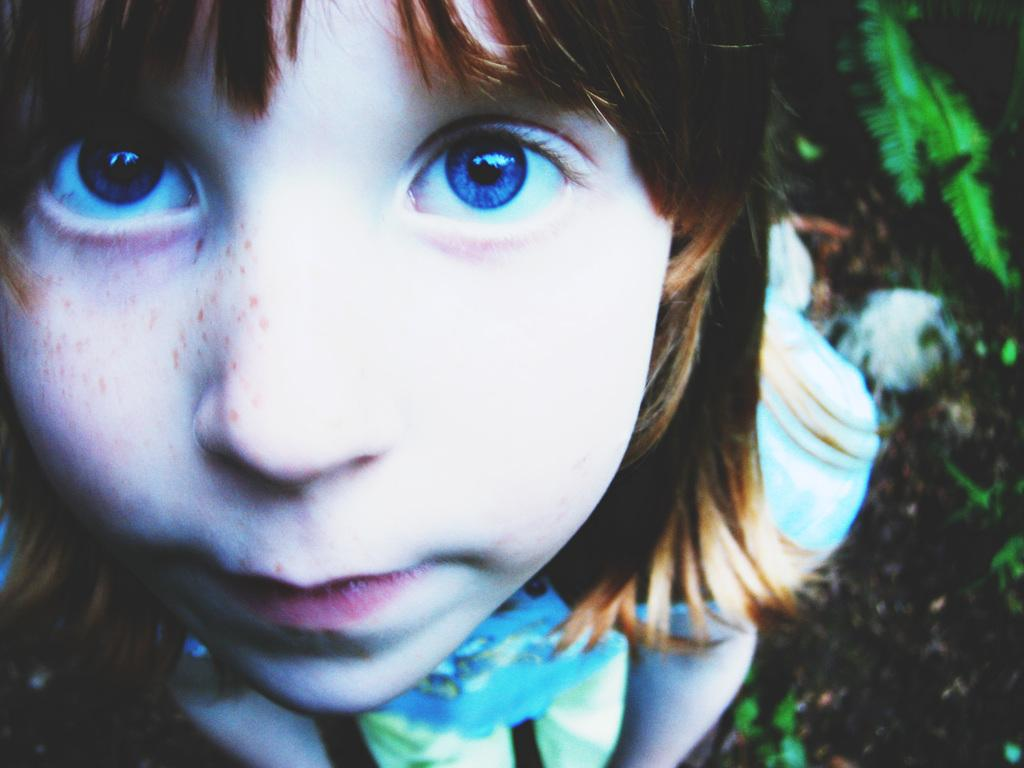Who or what is present in the image? There is a person in the image. What type of surface is visible in the image? There is ground visible in the image. What can be found on the ground in the image? There are objects on the ground in the image. What type of fruit can be seen growing on the person's feet in the image? There is no fruit or feet visible in the image; it only shows a person and objects on the ground. 